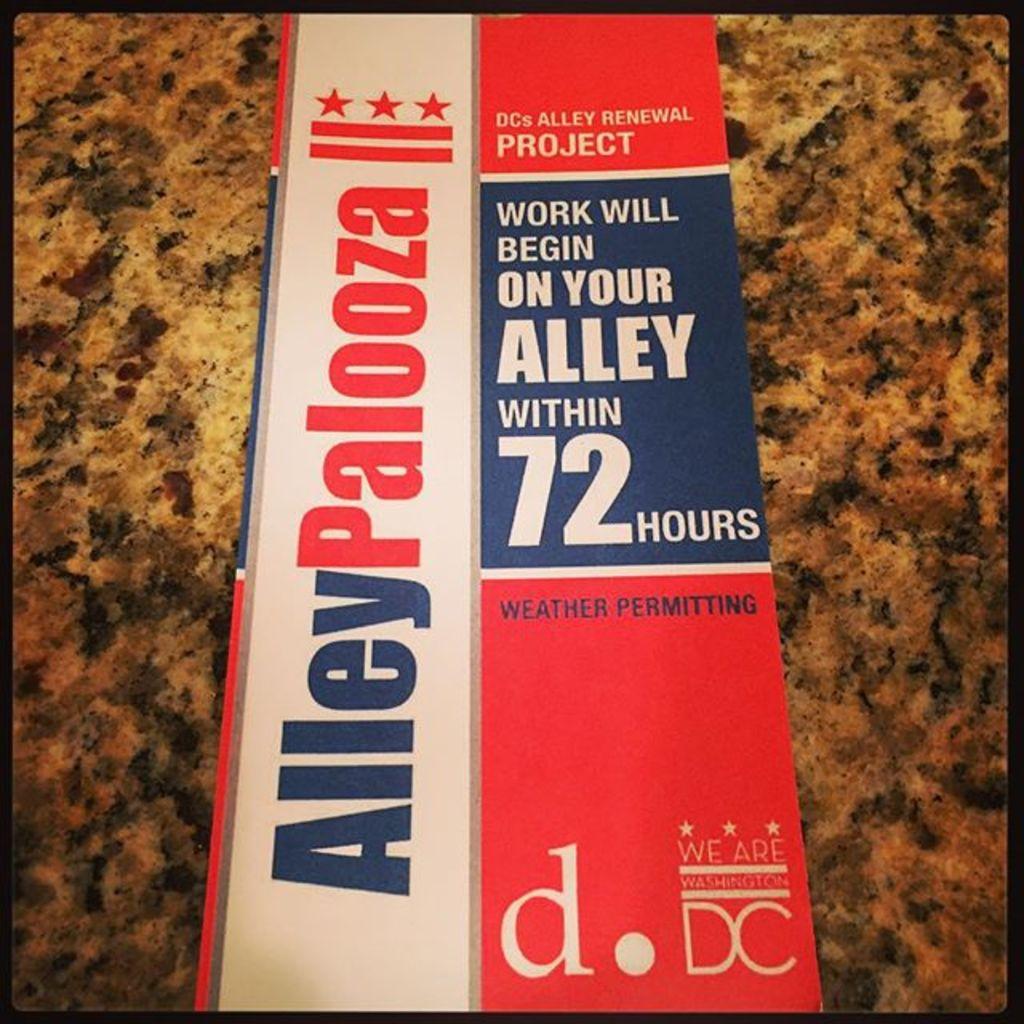Where is work going to begin within 72 hours?
Your answer should be compact. On your alley. What is the text in vertical letters?
Your response must be concise. Alleypalooza. 